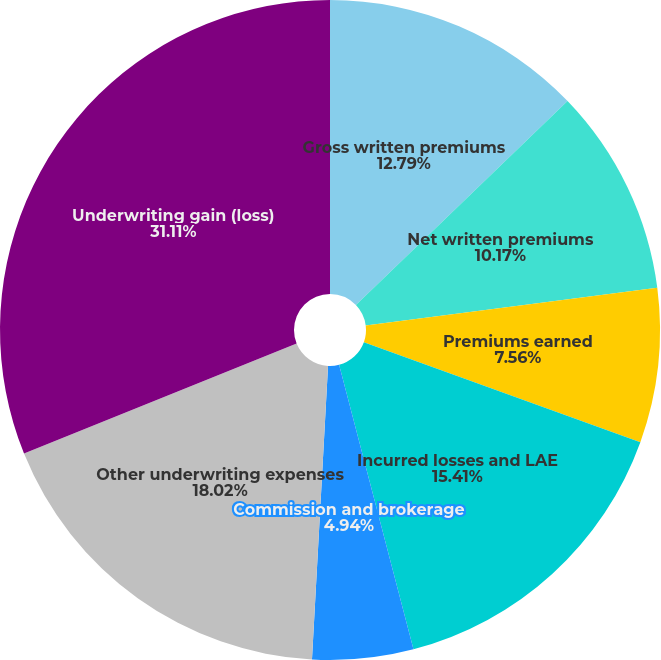<chart> <loc_0><loc_0><loc_500><loc_500><pie_chart><fcel>Gross written premiums<fcel>Net written premiums<fcel>Premiums earned<fcel>Incurred losses and LAE<fcel>Commission and brokerage<fcel>Other underwriting expenses<fcel>Underwriting gain (loss)<nl><fcel>12.79%<fcel>10.17%<fcel>7.56%<fcel>15.41%<fcel>4.94%<fcel>18.02%<fcel>31.11%<nl></chart> 